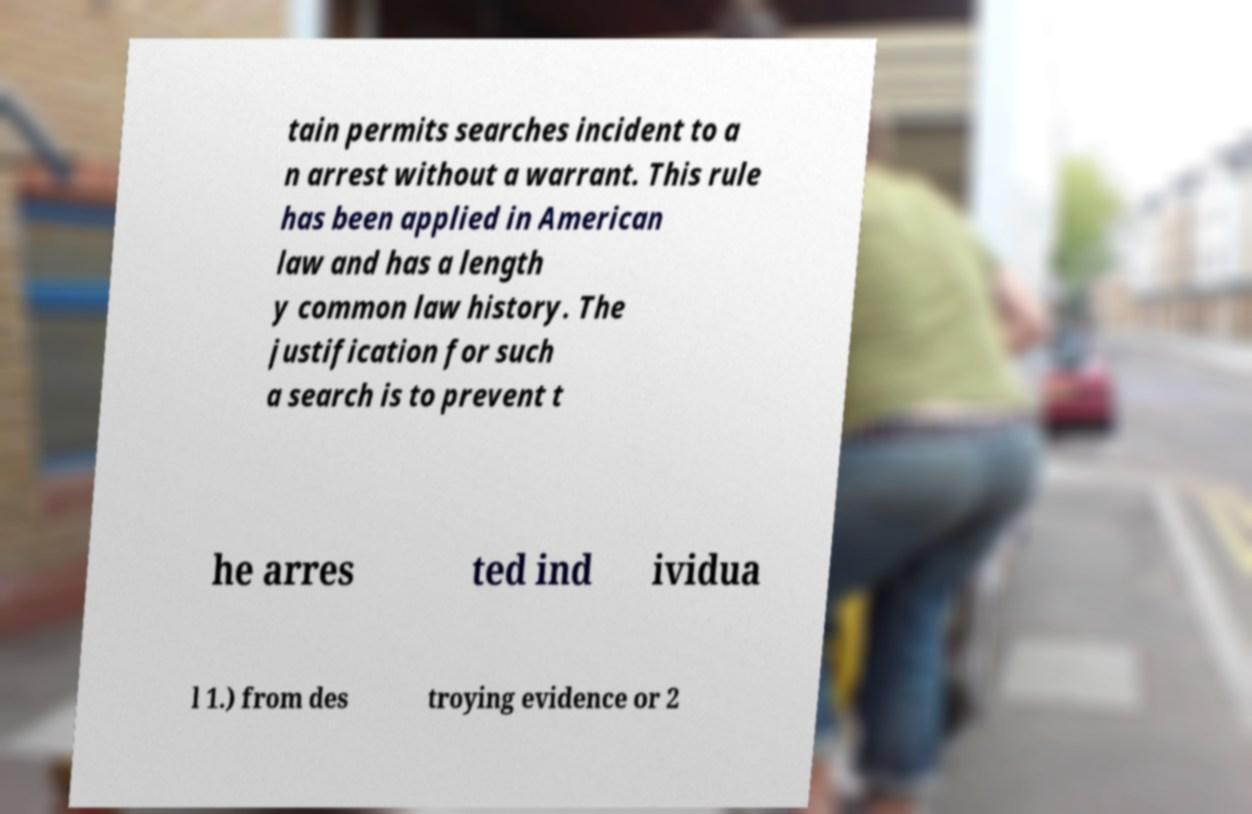There's text embedded in this image that I need extracted. Can you transcribe it verbatim? tain permits searches incident to a n arrest without a warrant. This rule has been applied in American law and has a length y common law history. The justification for such a search is to prevent t he arres ted ind ividua l 1.) from des troying evidence or 2 